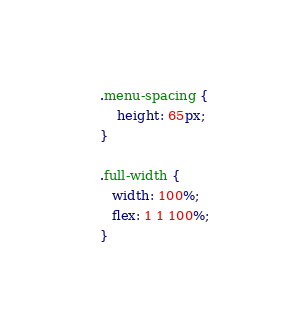<code> <loc_0><loc_0><loc_500><loc_500><_CSS_>
.menu-spacing {
    height: 65px;
}

.full-width {
   width: 100%; 
   flex: 1 1 100%;
}
</code> 